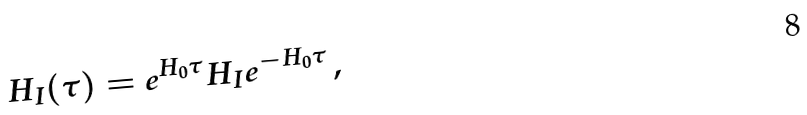Convert formula to latex. <formula><loc_0><loc_0><loc_500><loc_500>H _ { I } ( \tau ) = e ^ { H _ { 0 } \tau } H _ { I } e ^ { - H _ { 0 } \tau } \, ,</formula> 